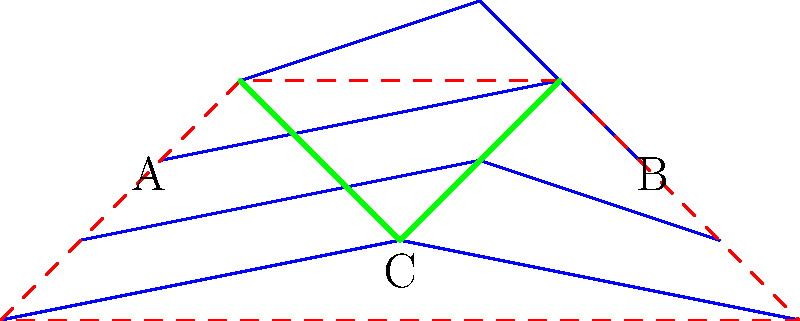Based on the topographic map shown, which point (A, B, or C) represents the outlet of the watershed, and what type of drainage pattern is exhibited within the watershed boundaries? To determine the watershed outlet and drainage pattern, let's analyze the map step-by-step:

1. Watershed boundary:
   - The red dashed line represents the watershed boundary, which is the ridge line separating different drainage areas.

2. Elevation contours:
   - Blue lines represent elevation contours, with higher elevations towards the top of the map.

3. Drainage pattern:
   - Green lines represent the flow of water within the watershed.

4. Identifying the outlet:
   - Water flows from higher to lower elevations, perpendicular to contour lines.
   - Point C is at the lowest elevation within the watershed boundary.
   - Both points A and B are at higher elevations than C.

5. Determining the drainage pattern:
   - Multiple smaller streams (green lines) converge towards a single point (C).
   - This pattern resembles tree branches joining a trunk.

6. Conclusion:
   - Point C is the watershed outlet, as it's the lowest point where water exits the watershed.
   - The drainage pattern is dendritic, characterized by a tree-like network of streams joining at acute angles.
Answer: Point C; Dendritic drainage pattern 